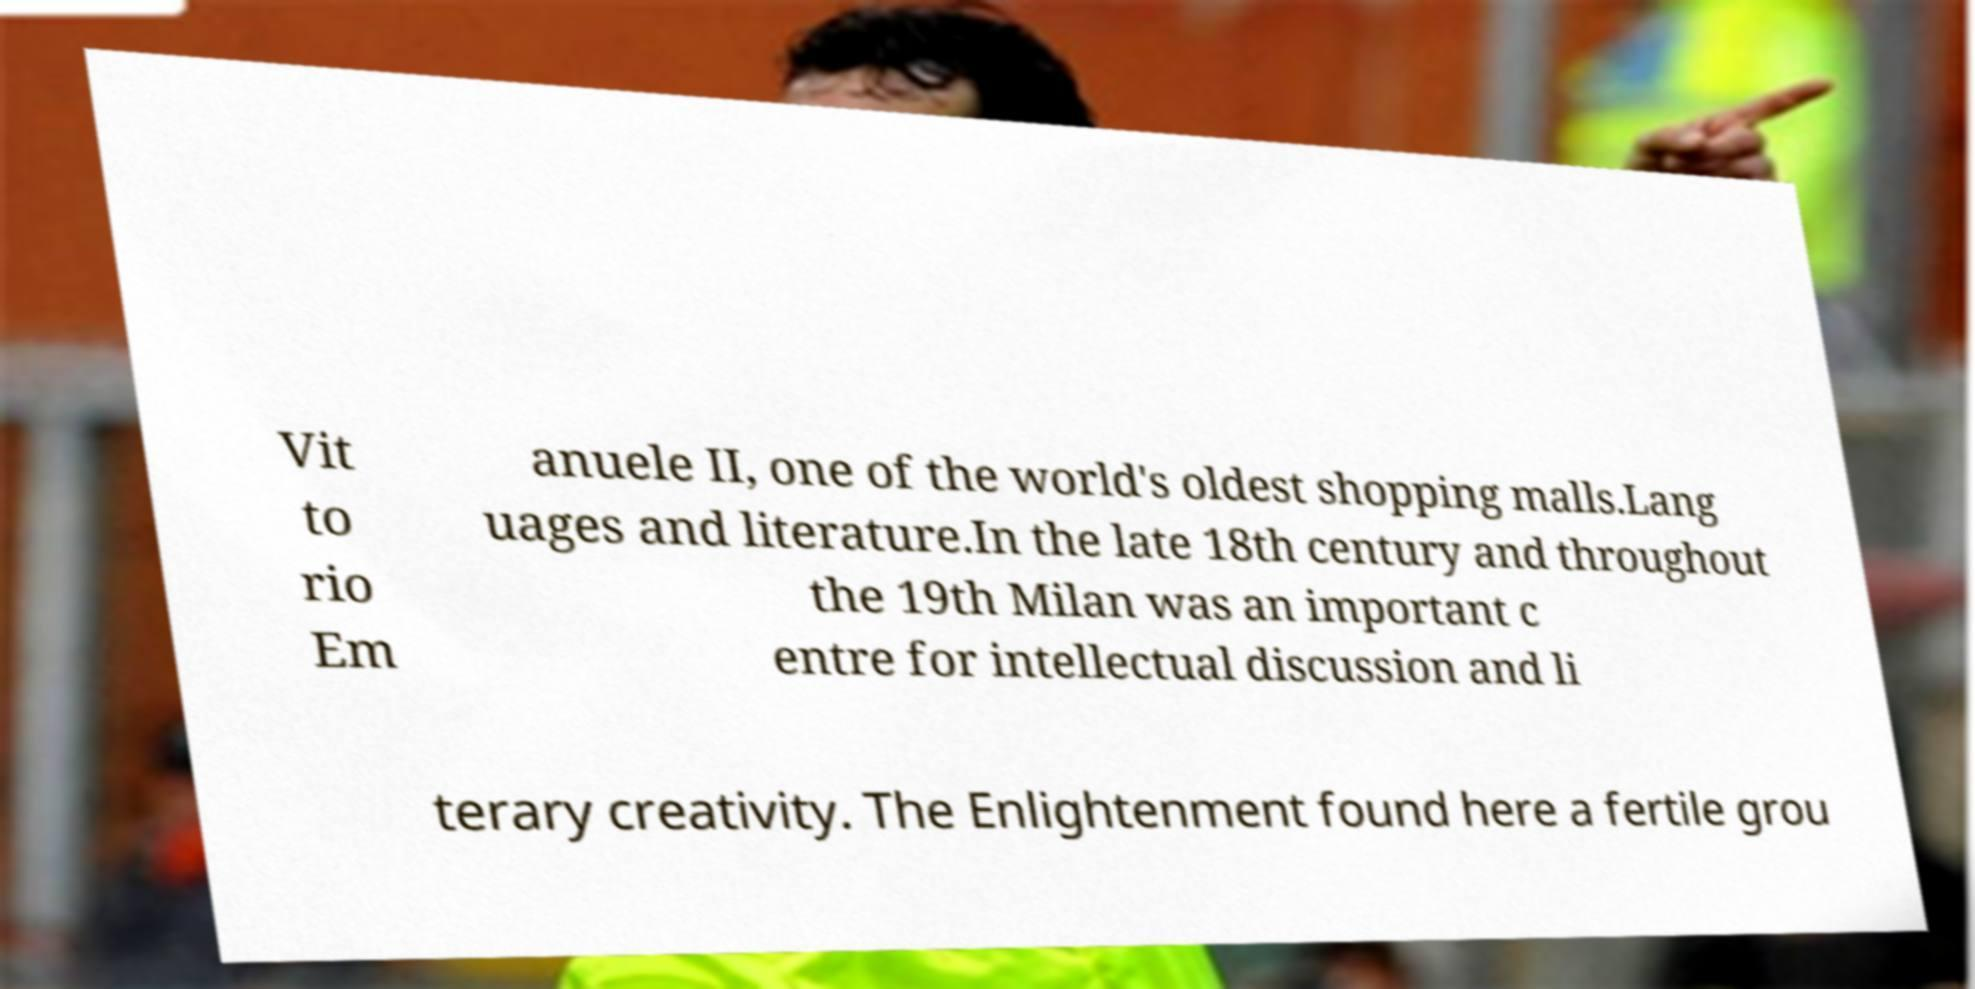There's text embedded in this image that I need extracted. Can you transcribe it verbatim? Vit to rio Em anuele II, one of the world's oldest shopping malls.Lang uages and literature.In the late 18th century and throughout the 19th Milan was an important c entre for intellectual discussion and li terary creativity. The Enlightenment found here a fertile grou 